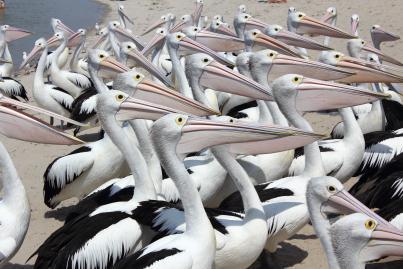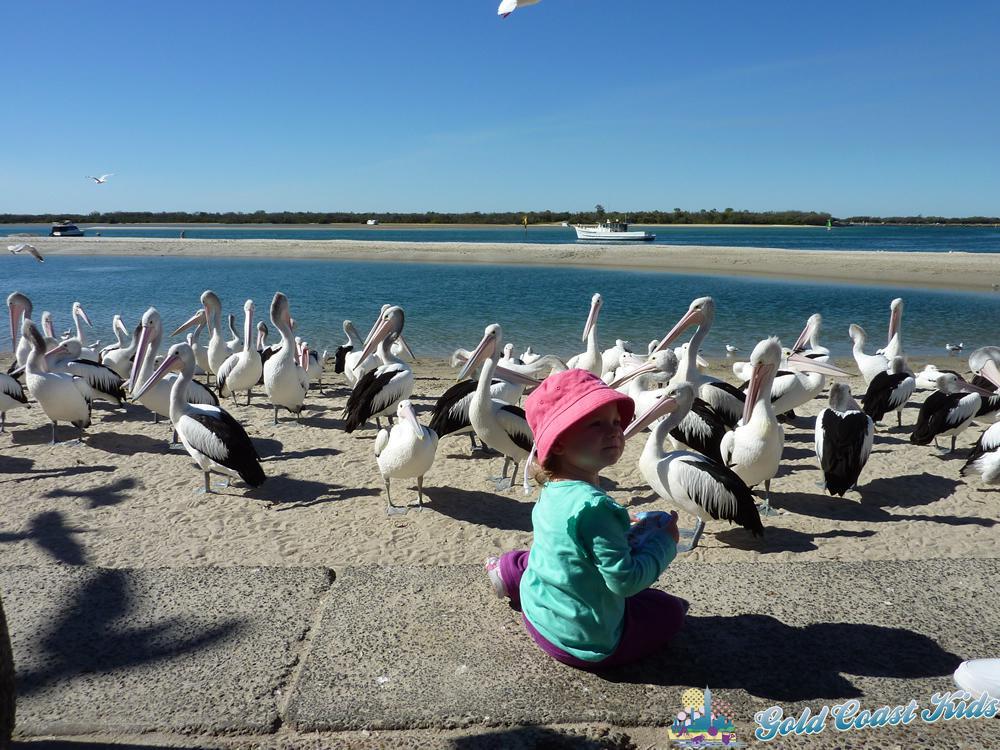The first image is the image on the left, the second image is the image on the right. Considering the images on both sides, is "In one of the photos in each pair is a man in a blue shirt surrounded by many pelicans and he is feeding them." valid? Answer yes or no. No. The first image is the image on the left, the second image is the image on the right. Given the left and right images, does the statement "At least one pelican has its mouth open." hold true? Answer yes or no. No. 